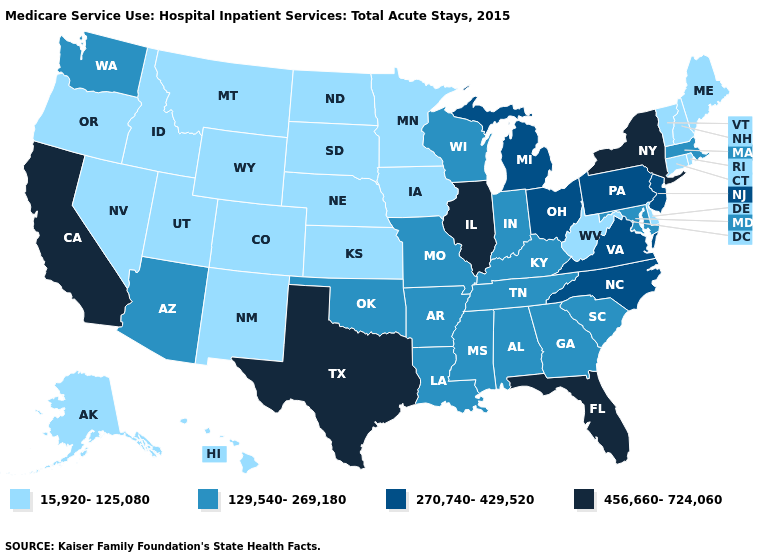Does Massachusetts have the highest value in the USA?
Quick response, please. No. What is the lowest value in the Northeast?
Be succinct. 15,920-125,080. Name the states that have a value in the range 15,920-125,080?
Give a very brief answer. Alaska, Colorado, Connecticut, Delaware, Hawaii, Idaho, Iowa, Kansas, Maine, Minnesota, Montana, Nebraska, Nevada, New Hampshire, New Mexico, North Dakota, Oregon, Rhode Island, South Dakota, Utah, Vermont, West Virginia, Wyoming. Name the states that have a value in the range 270,740-429,520?
Answer briefly. Michigan, New Jersey, North Carolina, Ohio, Pennsylvania, Virginia. Among the states that border Minnesota , which have the highest value?
Keep it brief. Wisconsin. Which states have the lowest value in the MidWest?
Keep it brief. Iowa, Kansas, Minnesota, Nebraska, North Dakota, South Dakota. Does Oregon have the lowest value in the USA?
Answer briefly. Yes. Does Illinois have a higher value than New Jersey?
Write a very short answer. Yes. What is the value of Delaware?
Concise answer only. 15,920-125,080. What is the value of California?
Write a very short answer. 456,660-724,060. Which states hav the highest value in the South?
Short answer required. Florida, Texas. Does Rhode Island have the lowest value in the USA?
Give a very brief answer. Yes. What is the highest value in the South ?
Be succinct. 456,660-724,060. What is the highest value in states that border Ohio?
Keep it brief. 270,740-429,520. Does Pennsylvania have the highest value in the Northeast?
Short answer required. No. 